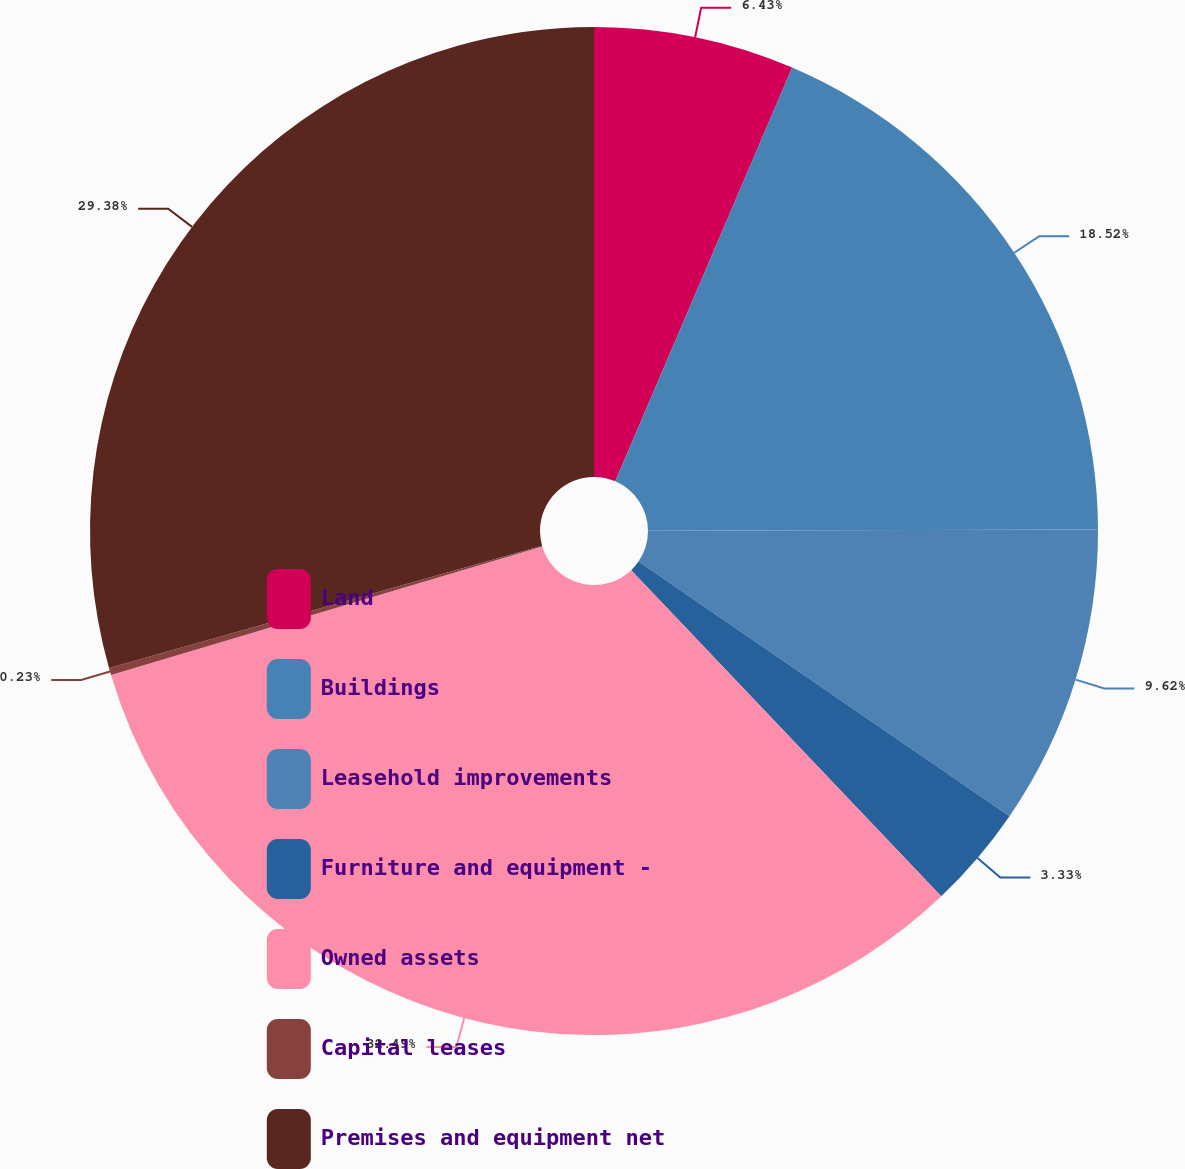Convert chart. <chart><loc_0><loc_0><loc_500><loc_500><pie_chart><fcel>Land<fcel>Buildings<fcel>Leasehold improvements<fcel>Furniture and equipment -<fcel>Owned assets<fcel>Capital leases<fcel>Premises and equipment net<nl><fcel>6.43%<fcel>18.52%<fcel>9.62%<fcel>3.33%<fcel>32.48%<fcel>0.23%<fcel>29.38%<nl></chart> 